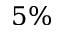<formula> <loc_0><loc_0><loc_500><loc_500>5 \%</formula> 